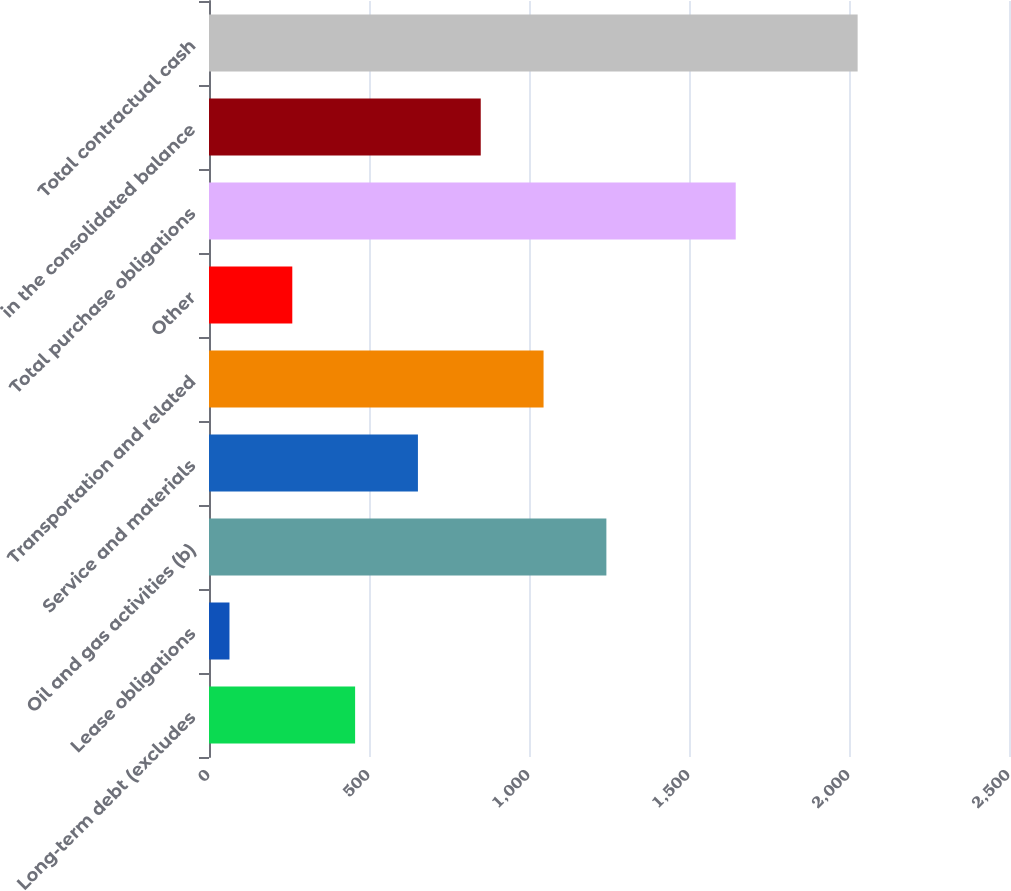<chart> <loc_0><loc_0><loc_500><loc_500><bar_chart><fcel>Long-term debt (excludes<fcel>Lease obligations<fcel>Oil and gas activities (b)<fcel>Service and materials<fcel>Transportation and related<fcel>Other<fcel>Total purchase obligations<fcel>in the consolidated balance<fcel>Total contractual cash<nl><fcel>456.6<fcel>64<fcel>1241.8<fcel>652.9<fcel>1045.5<fcel>260.3<fcel>1646<fcel>849.2<fcel>2027<nl></chart> 